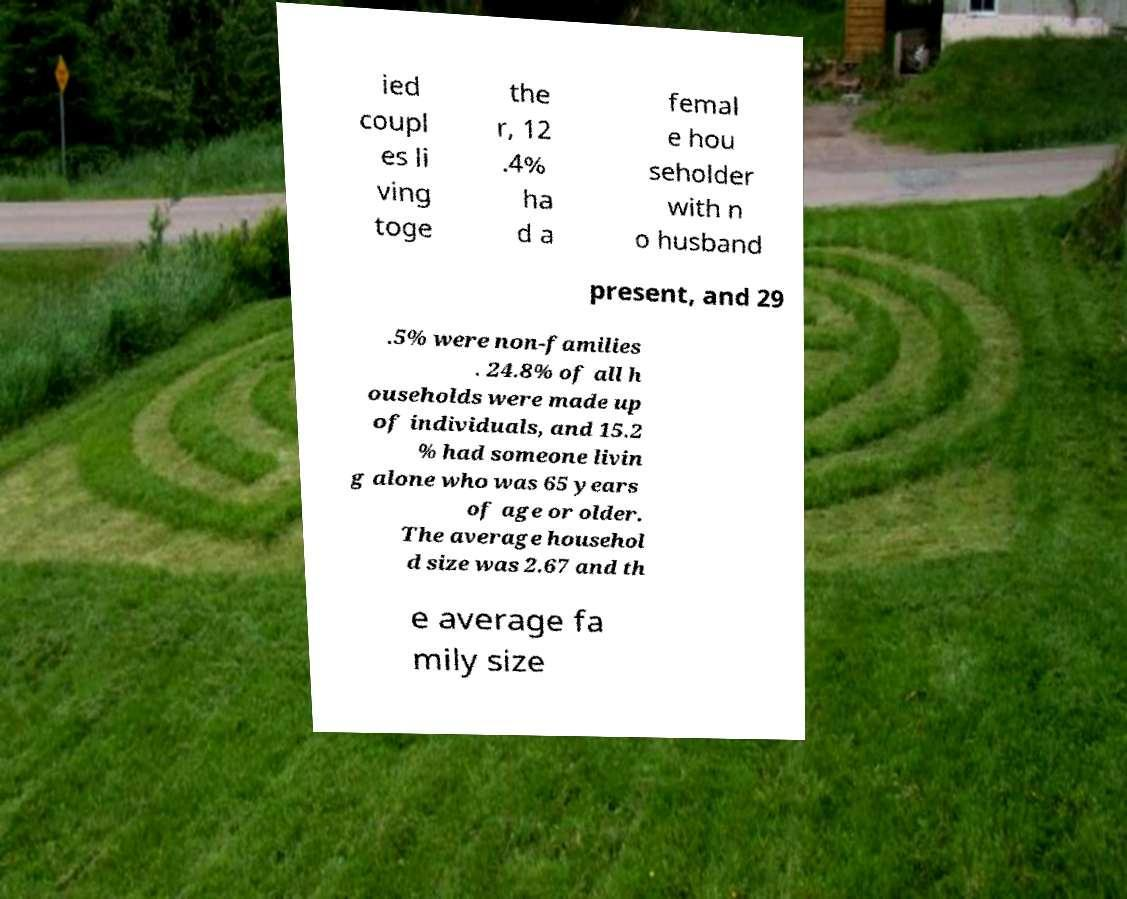I need the written content from this picture converted into text. Can you do that? ied coupl es li ving toge the r, 12 .4% ha d a femal e hou seholder with n o husband present, and 29 .5% were non-families . 24.8% of all h ouseholds were made up of individuals, and 15.2 % had someone livin g alone who was 65 years of age or older. The average househol d size was 2.67 and th e average fa mily size 